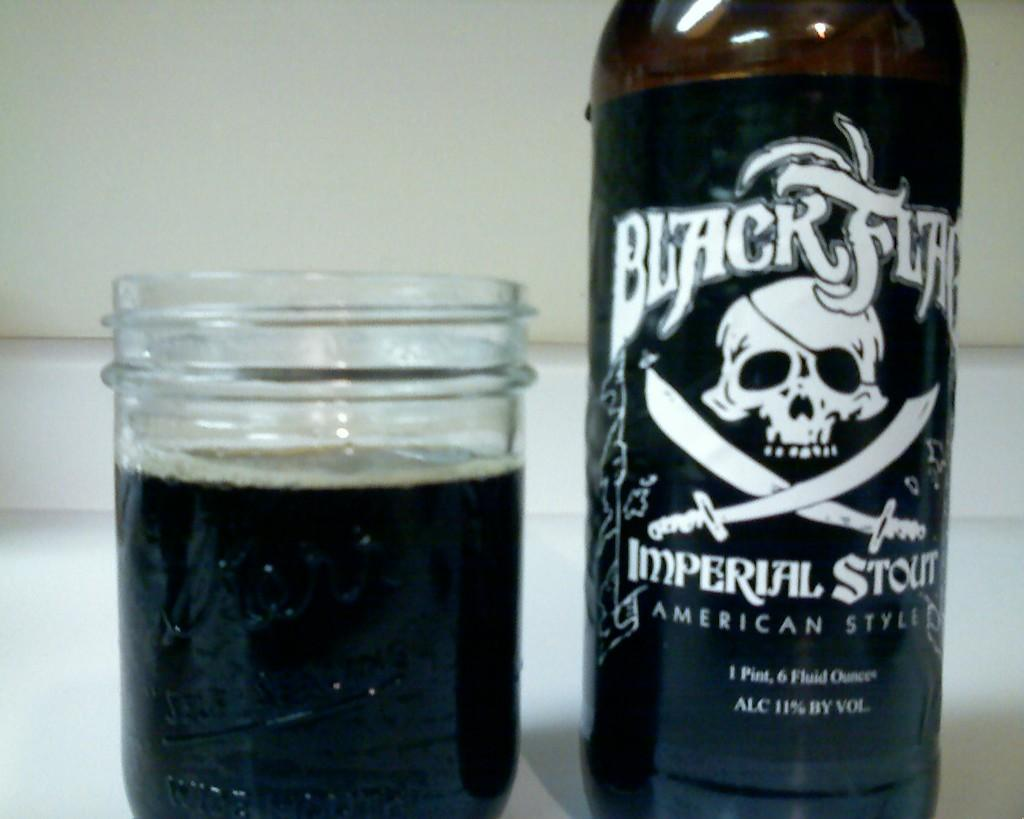<image>
Render a clear and concise summary of the photo. A black bottle of Imperial Stout, American Style with a glass jar nearby filled with some of the stout. 